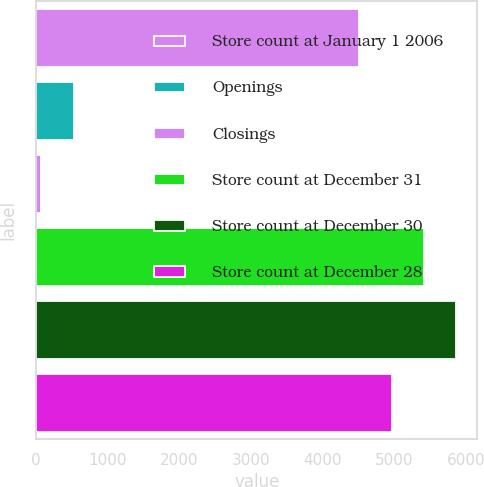Convert chart to OTSL. <chart><loc_0><loc_0><loc_500><loc_500><bar_chart><fcel>Store count at January 1 2006<fcel>Openings<fcel>Closings<fcel>Store count at December 31<fcel>Store count at December 30<fcel>Store count at December 28<nl><fcel>4511<fcel>523.2<fcel>72<fcel>5413.4<fcel>5864.6<fcel>4962.2<nl></chart> 